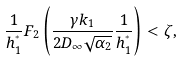Convert formula to latex. <formula><loc_0><loc_0><loc_500><loc_500>\frac { 1 } { h _ { 1 } ^ { ^ { * } } } F _ { 2 } \left ( \frac { \gamma k _ { 1 } } { 2 D _ { \infty } \sqrt { \alpha _ { 2 } } } \frac { 1 } { h _ { 1 } ^ { ^ { * } } } \right ) < \zeta ,</formula> 